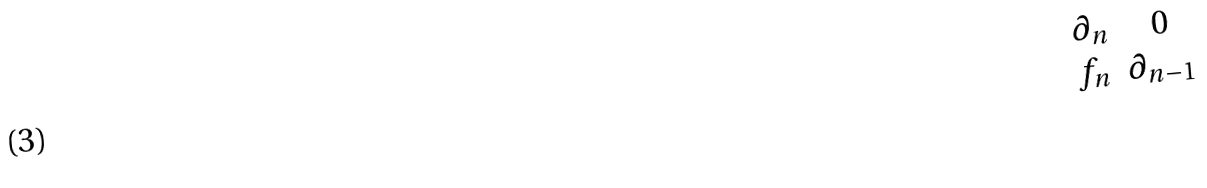Convert formula to latex. <formula><loc_0><loc_0><loc_500><loc_500>\begin{matrix} \partial _ { n } & 0 \\ f _ { n } & \partial _ { n - 1 } \end{matrix}</formula> 